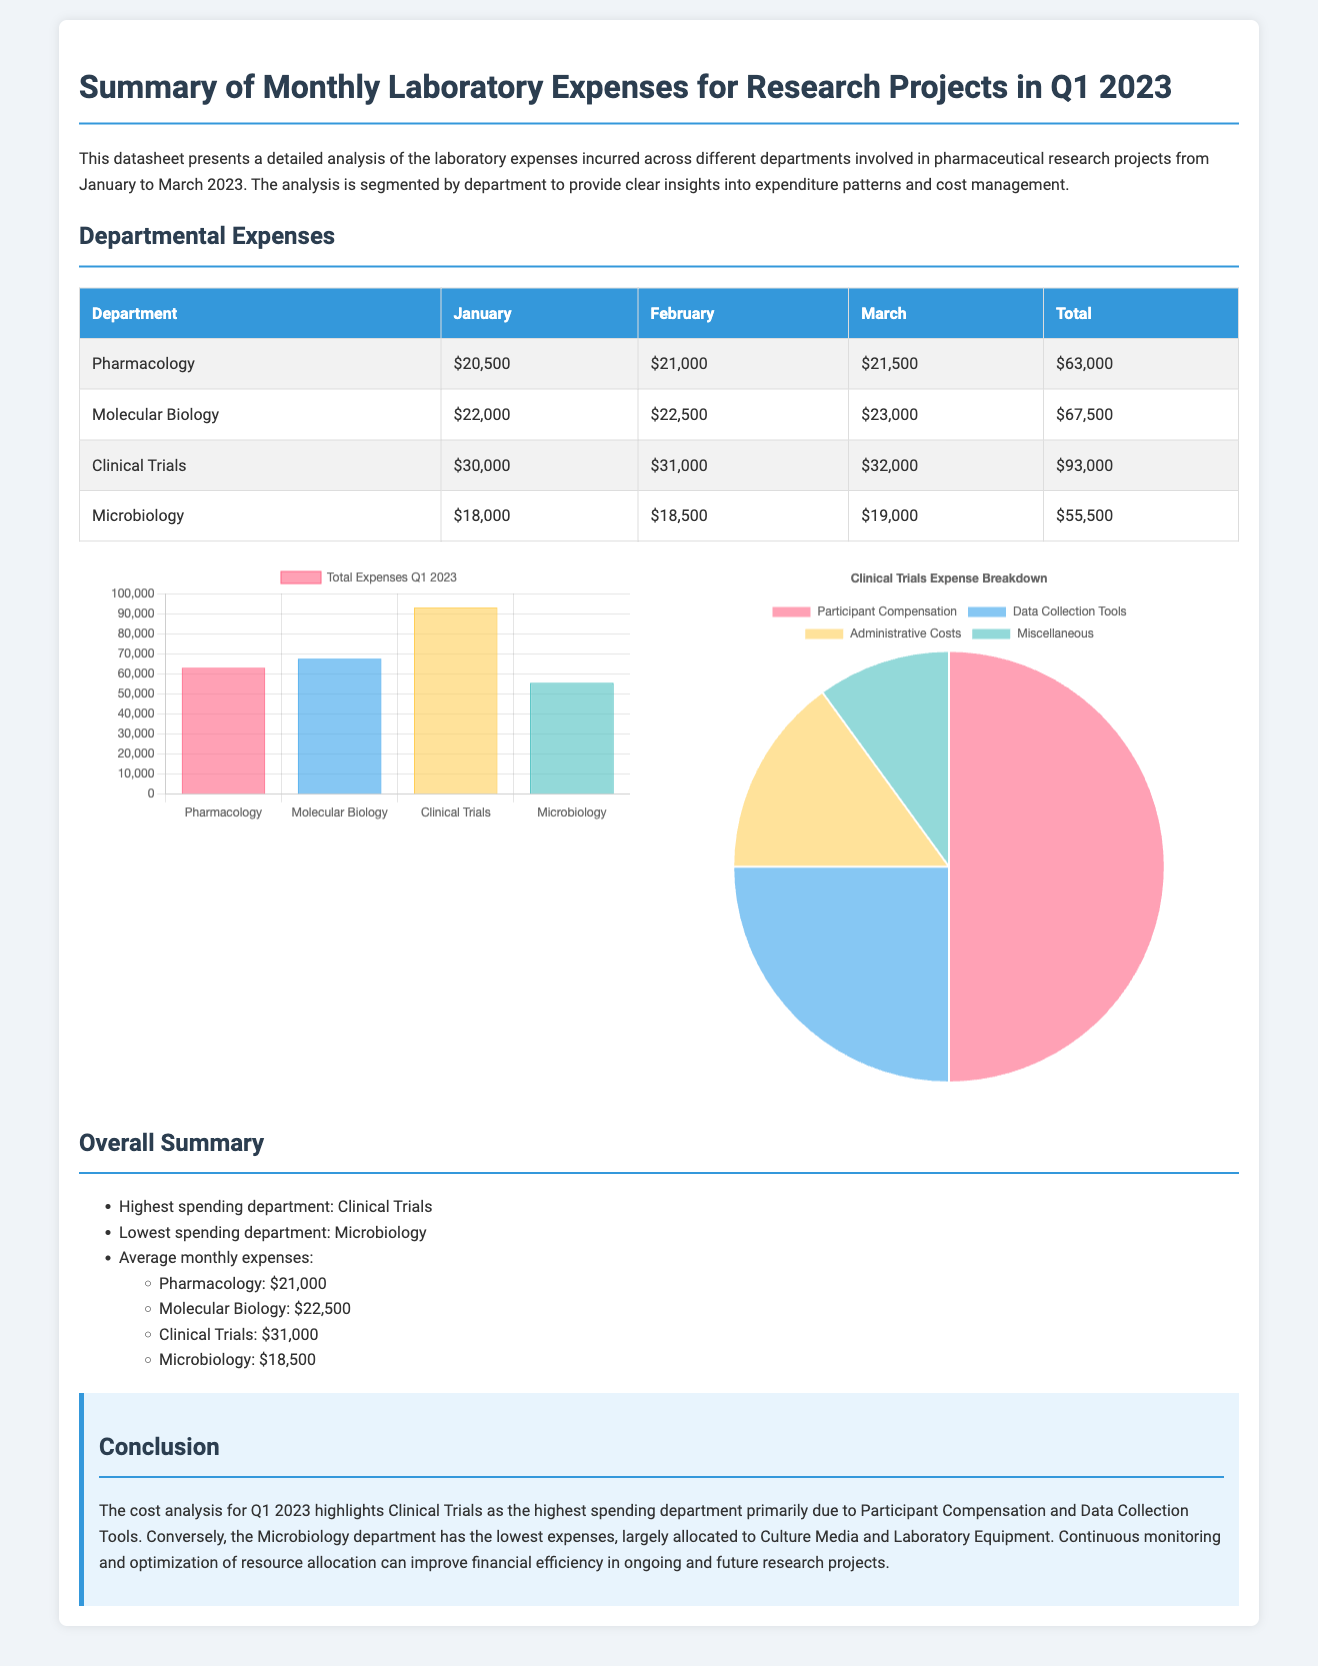what is the department with the highest expenses? The document states that Clinical Trials is the highest spending department.
Answer: Clinical Trials what is the total expense for Pharmacology in Q1 2023? The total expenses for Pharmacology is provided in the table as $63,000.
Answer: $63,000 how much did the Microbiology department spend in February? The table lists Microbiology's February expenses as $18,500.
Answer: $18,500 what was the average monthly expense for Molecular Biology? The average is calculated from the monthly expenses provided as $22,500.
Answer: $22,500 which department had the lowest spending? According to the overall summary, Microbiology is identified as the lowest spending department.
Answer: Microbiology what percentage of Clinical Trials budget is allocated to Participant Compensation? The subcategories chart indicates that 50% of the Clinical Trials budget is for Participant Compensation.
Answer: 50% what is the total amount spent by all departments in Q1 2023? The total is the sum of all department expenses: $63,000 + $67,500 + $93,000 + $55,500 = $279,000.
Answer: $279,000 what color represents Molecular Biology in the expenses chart? The chart uses the light blue color (rgba(54, 162, 235, 0.6)) for Molecular Biology.
Answer: Light blue how many months does this datasheet cover? The document outlines expenses for three months: January, February, and March 2023.
Answer: Three months 